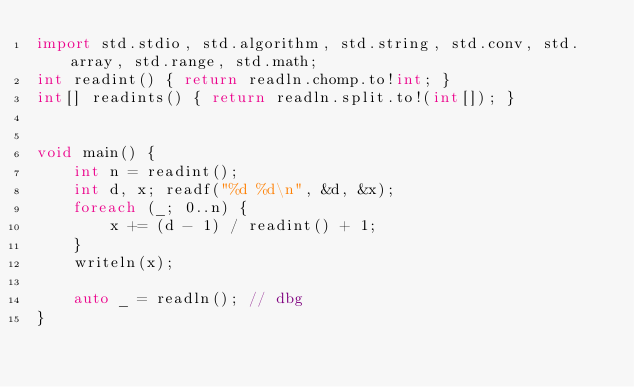<code> <loc_0><loc_0><loc_500><loc_500><_D_>import std.stdio, std.algorithm, std.string, std.conv, std.array, std.range, std.math;
int readint() { return readln.chomp.to!int; }
int[] readints() { return readln.split.to!(int[]); }


void main() {
    int n = readint();
    int d, x; readf("%d %d\n", &d, &x);
    foreach (_; 0..n) {
        x += (d - 1) / readint() + 1;
    }
    writeln(x);

    auto _ = readln(); // dbg
}</code> 